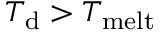<formula> <loc_0><loc_0><loc_500><loc_500>T _ { d } > T _ { m e l t }</formula> 